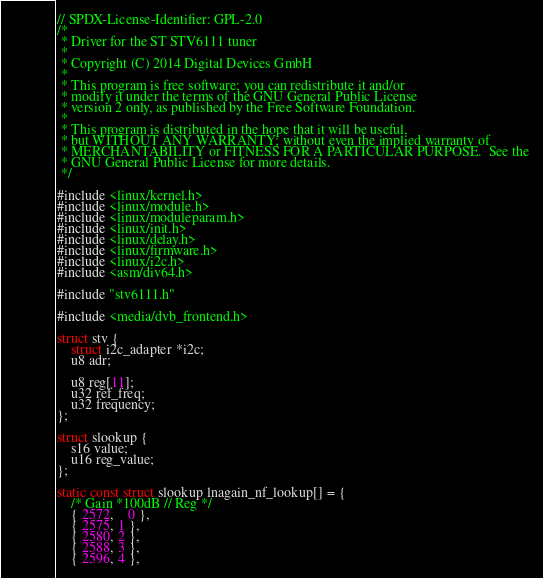Convert code to text. <code><loc_0><loc_0><loc_500><loc_500><_C_>// SPDX-License-Identifier: GPL-2.0
/*
 * Driver for the ST STV6111 tuner
 *
 * Copyright (C) 2014 Digital Devices GmbH
 *
 * This program is free software; you can redistribute it and/or
 * modify it under the terms of the GNU General Public License
 * version 2 only, as published by the Free Software Foundation.
 *
 * This program is distributed in the hope that it will be useful,
 * but WITHOUT ANY WARRANTY; without even the implied warranty of
 * MERCHANTABILITY or FITNESS FOR A PARTICULAR PURPOSE.  See the
 * GNU General Public License for more details.
 */

#include <linux/kernel.h>
#include <linux/module.h>
#include <linux/moduleparam.h>
#include <linux/init.h>
#include <linux/delay.h>
#include <linux/firmware.h>
#include <linux/i2c.h>
#include <asm/div64.h>

#include "stv6111.h"

#include <media/dvb_frontend.h>

struct stv {
	struct i2c_adapter *i2c;
	u8 adr;

	u8 reg[11];
	u32 ref_freq;
	u32 frequency;
};

struct slookup {
	s16 value;
	u16 reg_value;
};

static const struct slookup lnagain_nf_lookup[] = {
	/* Gain *100dB // Reg */
	{ 2572,	0 },
	{ 2575, 1 },
	{ 2580, 2 },
	{ 2588, 3 },
	{ 2596, 4 },</code> 